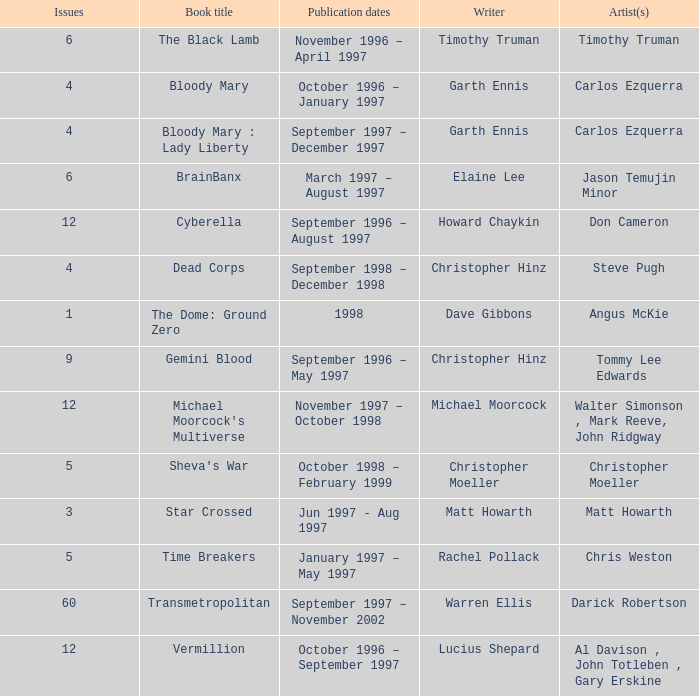What artist has a book called cyberella Don Cameron. 